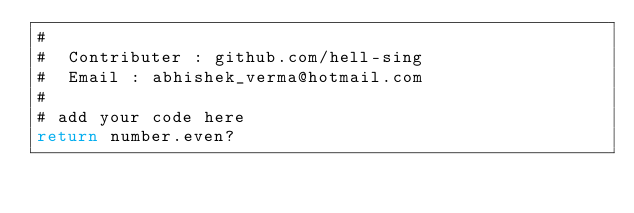Convert code to text. <code><loc_0><loc_0><loc_500><loc_500><_Ruby_>#
#  Contributer : github.com/hell-sing
#  Email : abhishek_verma@hotmail.com
#
# add your code here
return number.even?
</code> 